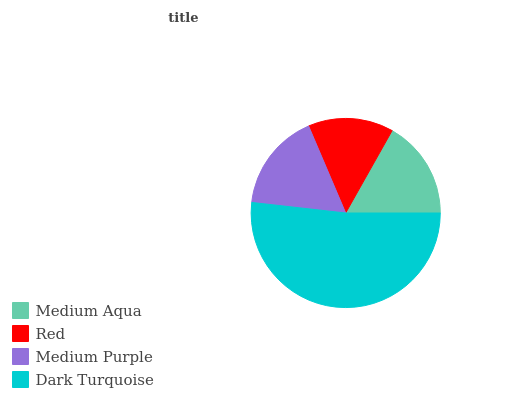Is Red the minimum?
Answer yes or no. Yes. Is Dark Turquoise the maximum?
Answer yes or no. Yes. Is Medium Purple the minimum?
Answer yes or no. No. Is Medium Purple the maximum?
Answer yes or no. No. Is Medium Purple greater than Red?
Answer yes or no. Yes. Is Red less than Medium Purple?
Answer yes or no. Yes. Is Red greater than Medium Purple?
Answer yes or no. No. Is Medium Purple less than Red?
Answer yes or no. No. Is Medium Aqua the high median?
Answer yes or no. Yes. Is Medium Purple the low median?
Answer yes or no. Yes. Is Medium Purple the high median?
Answer yes or no. No. Is Medium Aqua the low median?
Answer yes or no. No. 